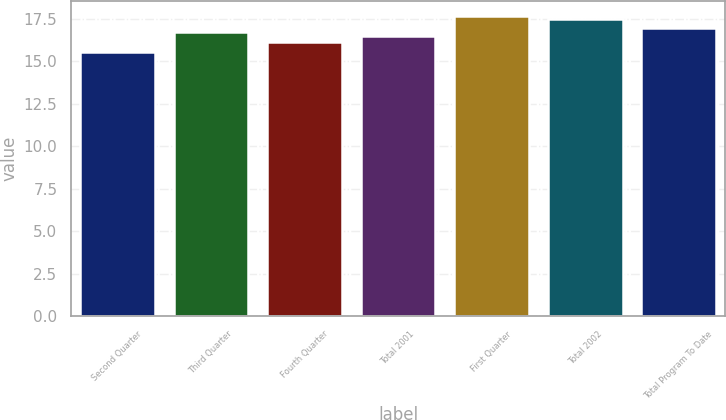Convert chart to OTSL. <chart><loc_0><loc_0><loc_500><loc_500><bar_chart><fcel>Second Quarter<fcel>Third Quarter<fcel>Fourth Quarter<fcel>Total 2001<fcel>First Quarter<fcel>Total 2002<fcel>Total Program To Date<nl><fcel>15.55<fcel>16.75<fcel>16.12<fcel>16.5<fcel>17.67<fcel>17.47<fcel>16.95<nl></chart> 